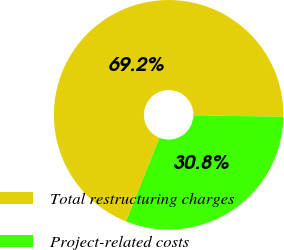<chart> <loc_0><loc_0><loc_500><loc_500><pie_chart><fcel>Total restructuring charges<fcel>Project-related costs<nl><fcel>69.23%<fcel>30.77%<nl></chart> 